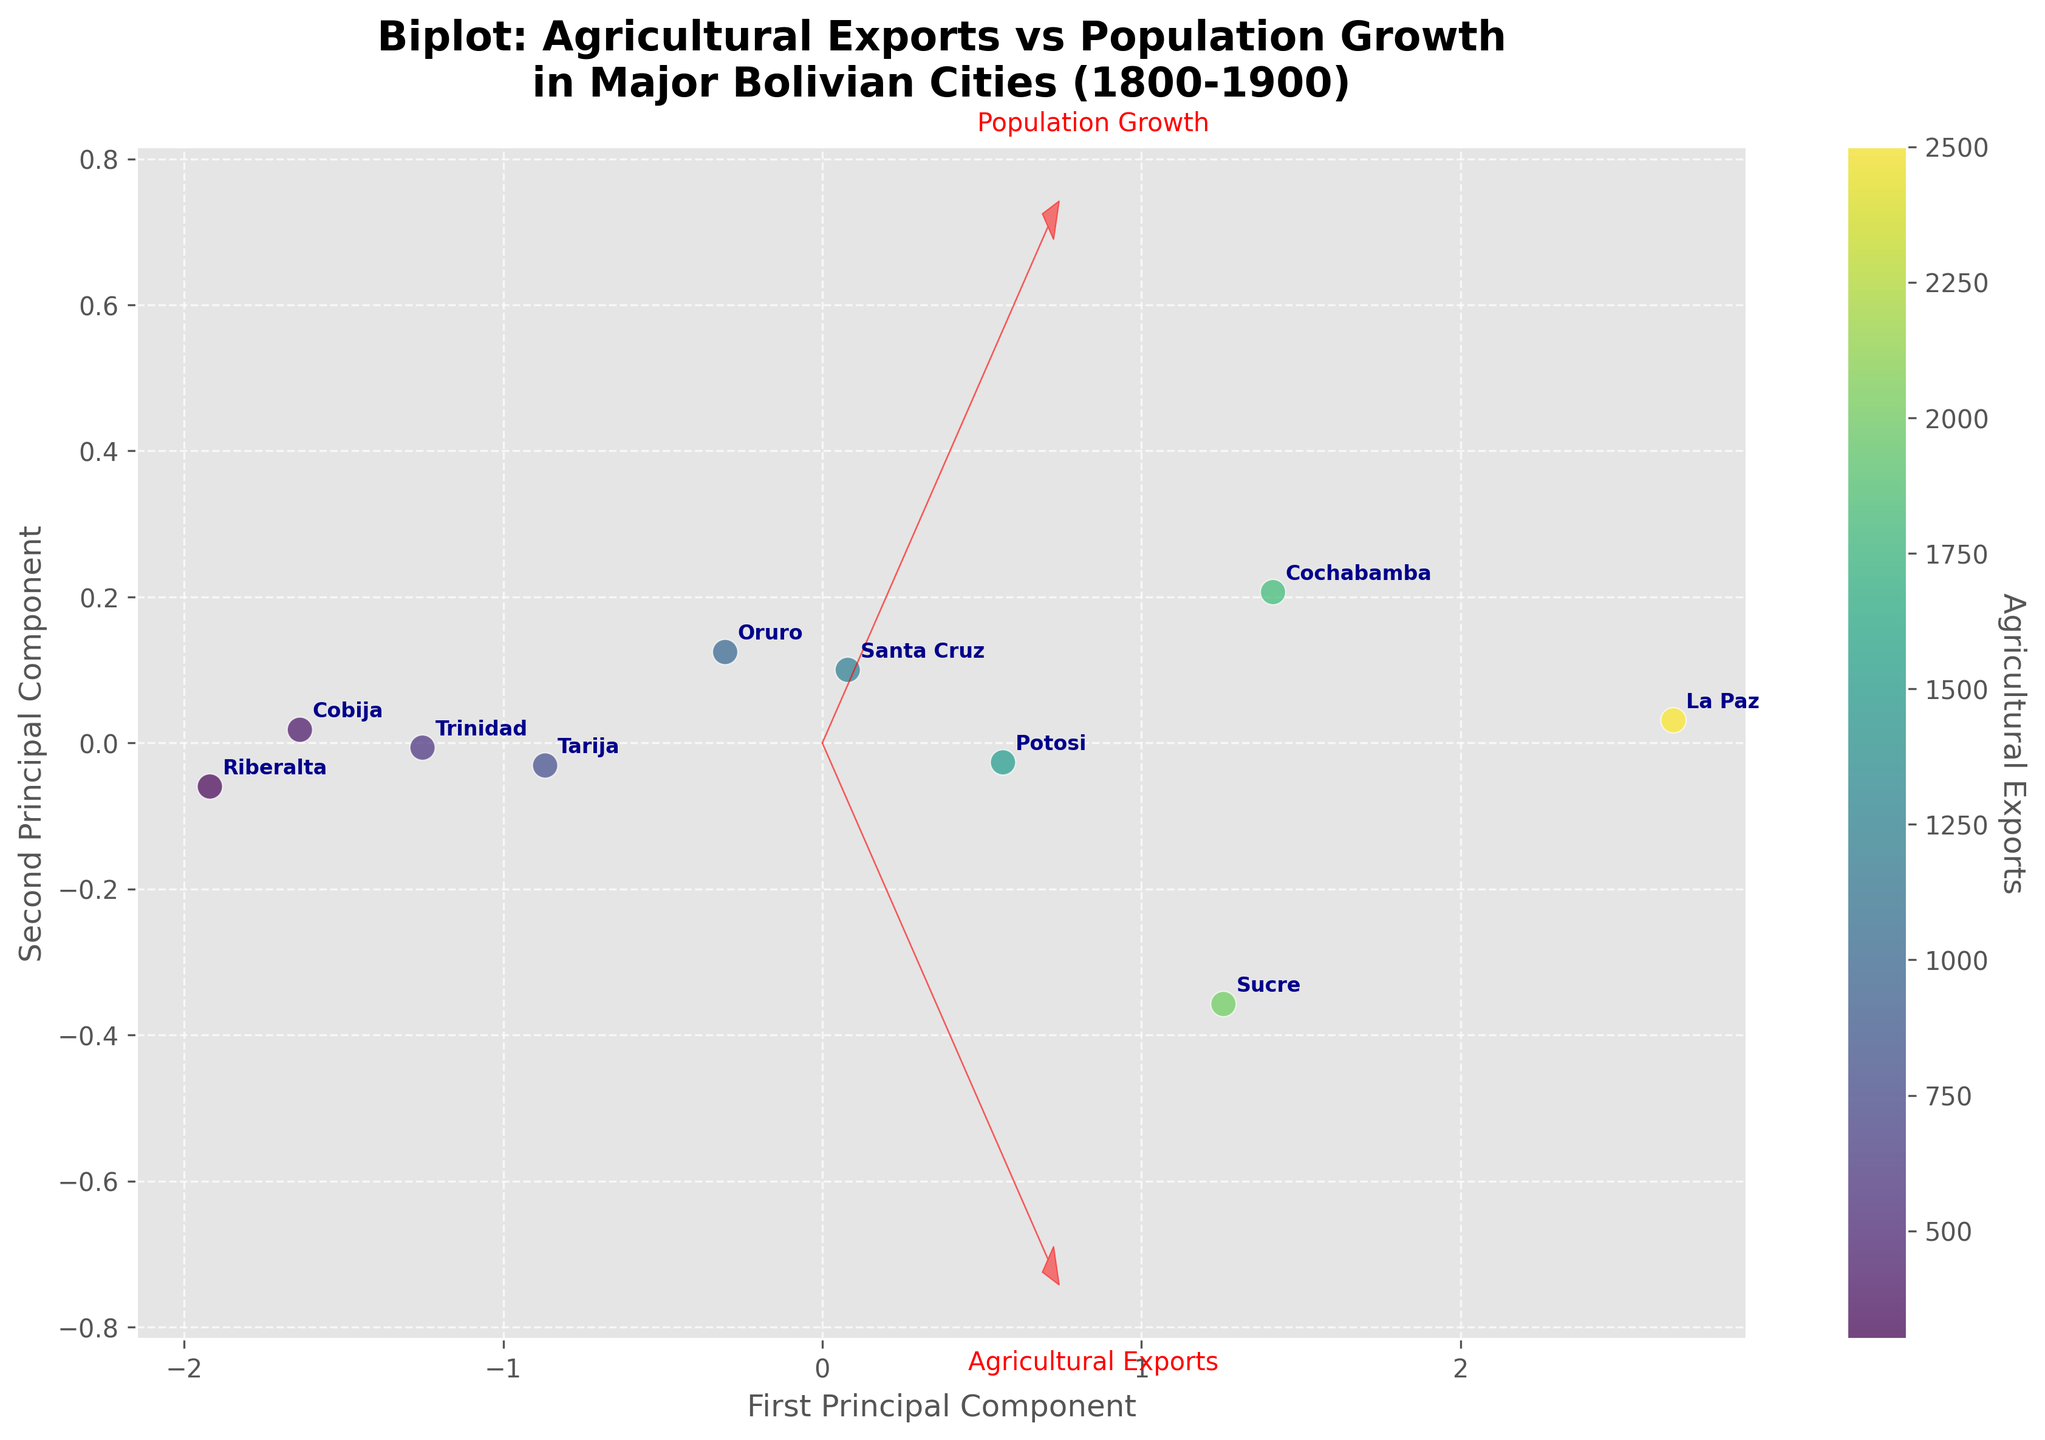How many cities are represented in the biplot? There are 10 points in the biplot, each labeled with a city name.
Answer: 10 What is the title of the biplot? The title is displayed at the top of the biplot.
Answer: "Biplot: Agricultural Exports vs Population Growth in Major Bolivian Cities (1800-1900)" Which city has the highest Agricultural Exports? The color gradient indicates Agricultural Exports, with La Paz having the darkest shade.
Answer: La Paz Which city has the lowest Population Growth? The position of the points along the second principal component axis indicates Population Growth, Riberalta is the lowest.
Answer: Riberalta What is the label of the arrow pointing more horizontally? The horizontal direction refers to the first principal component, which corresponds to Agricultural Exports.
Answer: Agricultural Exports Which city appears closest to the origin in the biplot? The point nearest to (0,0) can be identified by examining the plot, Cobija is closest.
Answer: Cobija How do agricultural exports and population growth relate across cities? Arrows show correlation direction, the Agricultural Exports arrow is roughly horizontal and Population Growth is more vertical, suggesting they follow different patterns.
Answer: Not strongly related Which two cities have similar positions on the biplot? Proximity in the biplot indicates similarity in standardized scores. Sucre and Potosi are closest.
Answer: Sucre and Potosi What is the color representing the second lowest Agricultural Exports? The second lightest shade of color gradient in scatter points represents the second lowest value, which is Cobija.
Answer: Cobija 